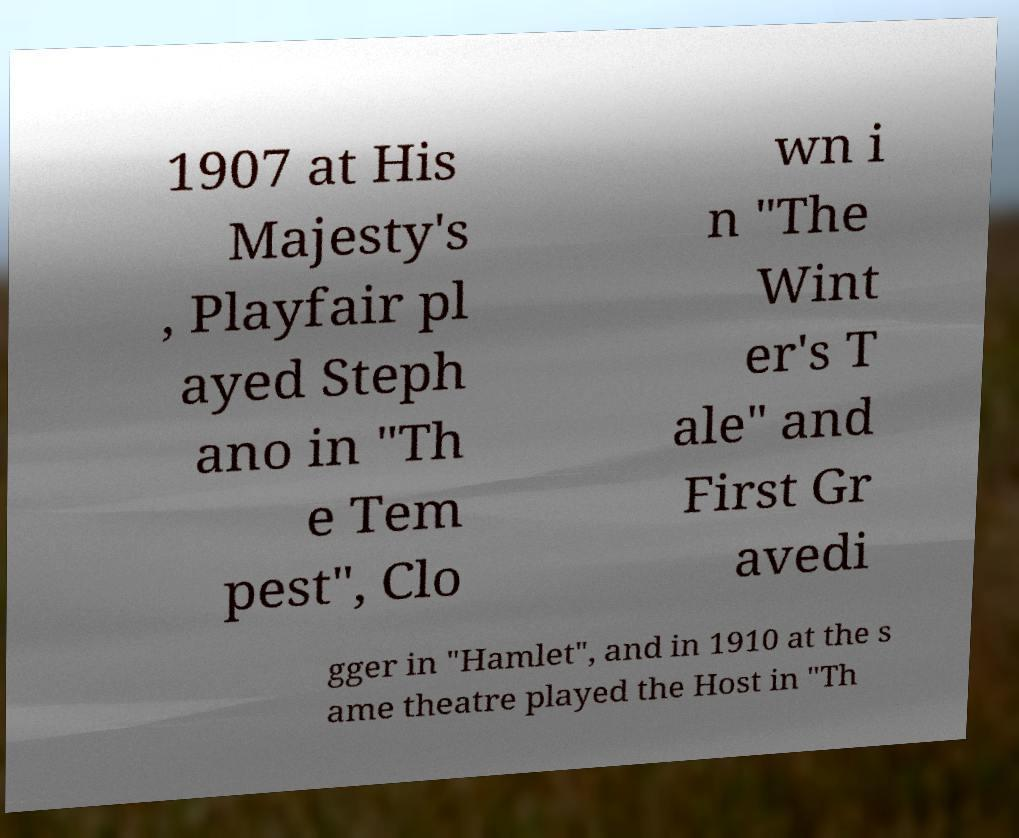Please read and relay the text visible in this image. What does it say? 1907 at His Majesty's , Playfair pl ayed Steph ano in "Th e Tem pest", Clo wn i n "The Wint er's T ale" and First Gr avedi gger in "Hamlet", and in 1910 at the s ame theatre played the Host in "Th 